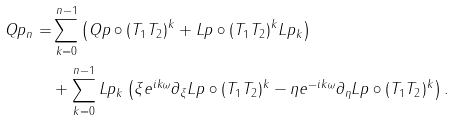Convert formula to latex. <formula><loc_0><loc_0><loc_500><loc_500>Q p _ { n } = & \sum _ { k = 0 } ^ { n - 1 } \left ( Q p \circ ( T _ { 1 } T _ { 2 } ) ^ { k } + L p \circ ( T _ { 1 } T _ { 2 } ) ^ { k } L p _ { k } \right ) \\ & + \sum _ { k = 0 } ^ { n - 1 } L p _ { k } \left ( \xi e ^ { i k \omega } \partial _ { \xi } L p \circ ( T _ { 1 } T _ { 2 } ) ^ { k } - \eta e ^ { - i k \omega } \partial _ { \eta } L p \circ ( T _ { 1 } T _ { 2 } ) ^ { k } \right ) .</formula> 